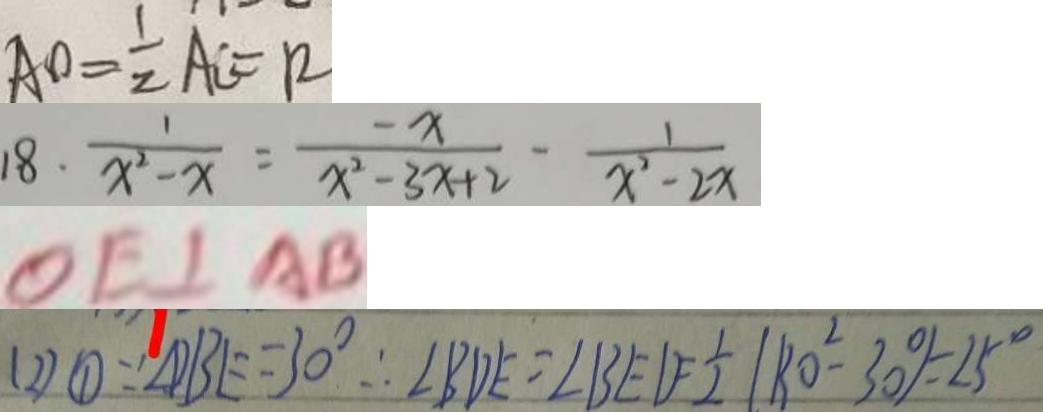Convert formula to latex. <formula><loc_0><loc_0><loc_500><loc_500>A O = \frac { 1 } { 2 } A C = R 
 1 8 . \frac { 1 } { x ^ { 2 } - x } = \frac { - x } { x ^ { 2 } - 3 x + 2 } - \frac { 1 } { x ^ { 2 } - 2 x } 
 O E \bot A B 
 ( 2 ) \textcircled { 1 } \because \angle D B E = 3 0 ^ { \circ } \therefore \angle B D E = \angle B E D = \frac { 1 } { 2 } ( 8 0 ^ { 2 } - 3 0 \% ) = 2 5 ^ { \circ }</formula> 